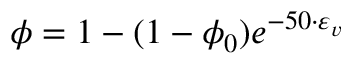<formula> <loc_0><loc_0><loc_500><loc_500>\phi = 1 - ( 1 - \phi _ { 0 } ) e ^ { - 5 0 \cdot \varepsilon _ { v } }</formula> 